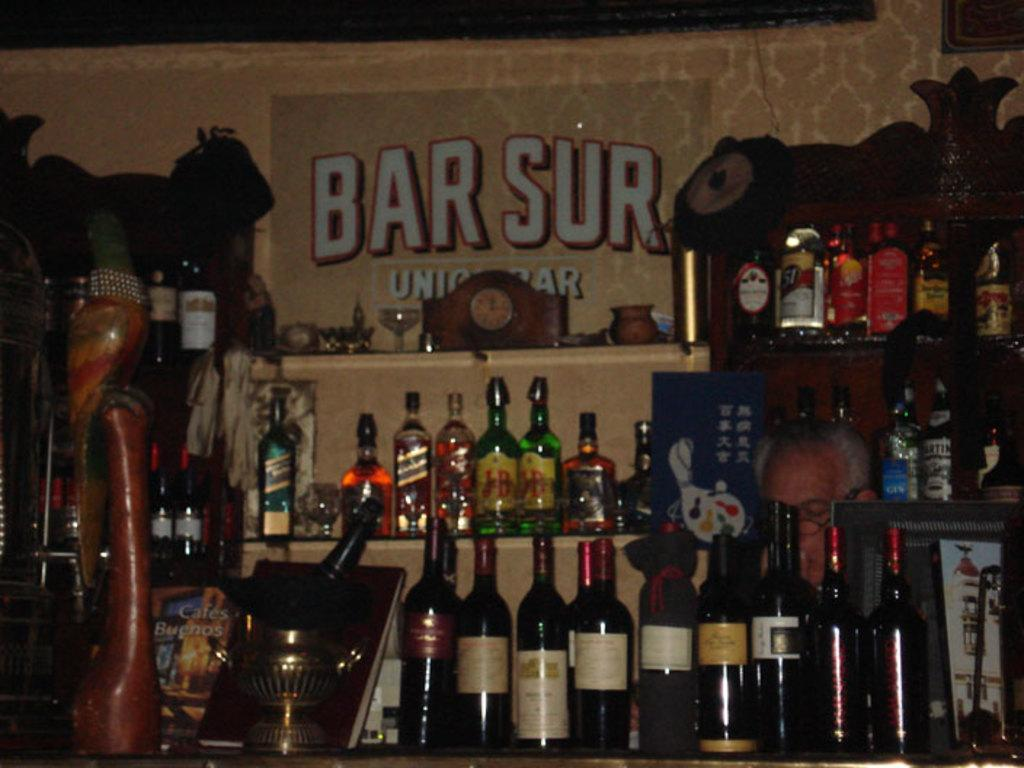Provide a one-sentence caption for the provided image. Bottles of wine line up in front of a wall with Bar Sur on it. 